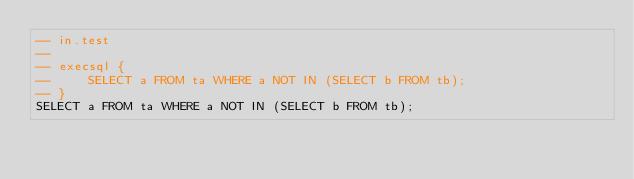<code> <loc_0><loc_0><loc_500><loc_500><_SQL_>-- in.test
-- 
-- execsql {
--     SELECT a FROM ta WHERE a NOT IN (SELECT b FROM tb);
-- }
SELECT a FROM ta WHERE a NOT IN (SELECT b FROM tb);</code> 